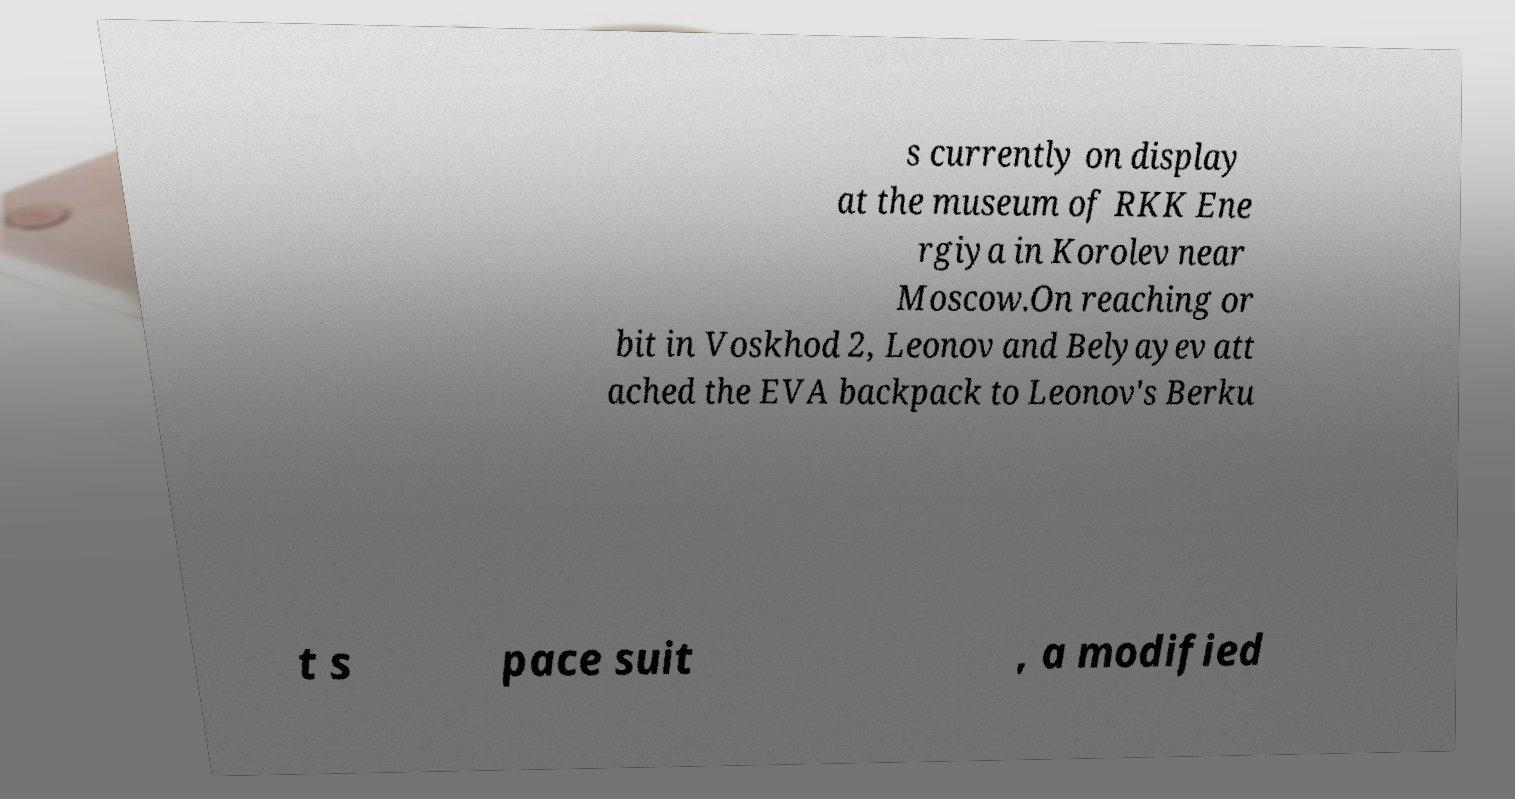Can you accurately transcribe the text from the provided image for me? s currently on display at the museum of RKK Ene rgiya in Korolev near Moscow.On reaching or bit in Voskhod 2, Leonov and Belyayev att ached the EVA backpack to Leonov's Berku t s pace suit , a modified 